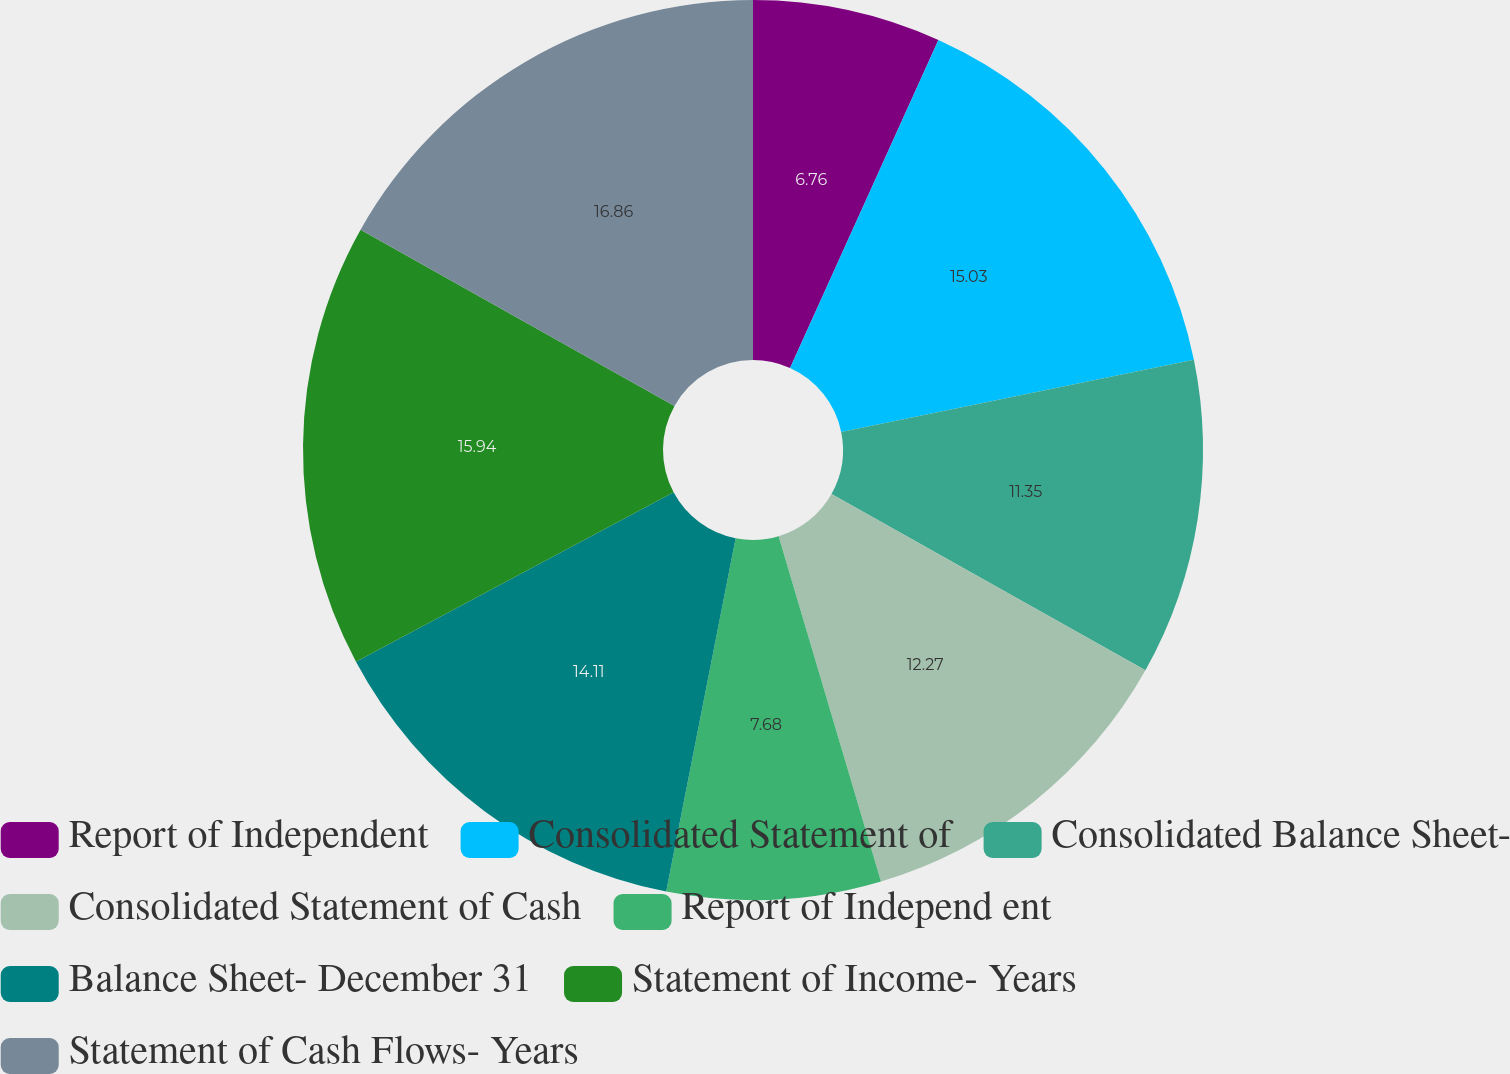<chart> <loc_0><loc_0><loc_500><loc_500><pie_chart><fcel>Report of Independent<fcel>Consolidated Statement of<fcel>Consolidated Balance Sheet-<fcel>Consolidated Statement of Cash<fcel>Report of Independ ent<fcel>Balance Sheet- December 31<fcel>Statement of Income- Years<fcel>Statement of Cash Flows- Years<nl><fcel>6.76%<fcel>15.03%<fcel>11.35%<fcel>12.27%<fcel>7.68%<fcel>14.11%<fcel>15.94%<fcel>16.86%<nl></chart> 